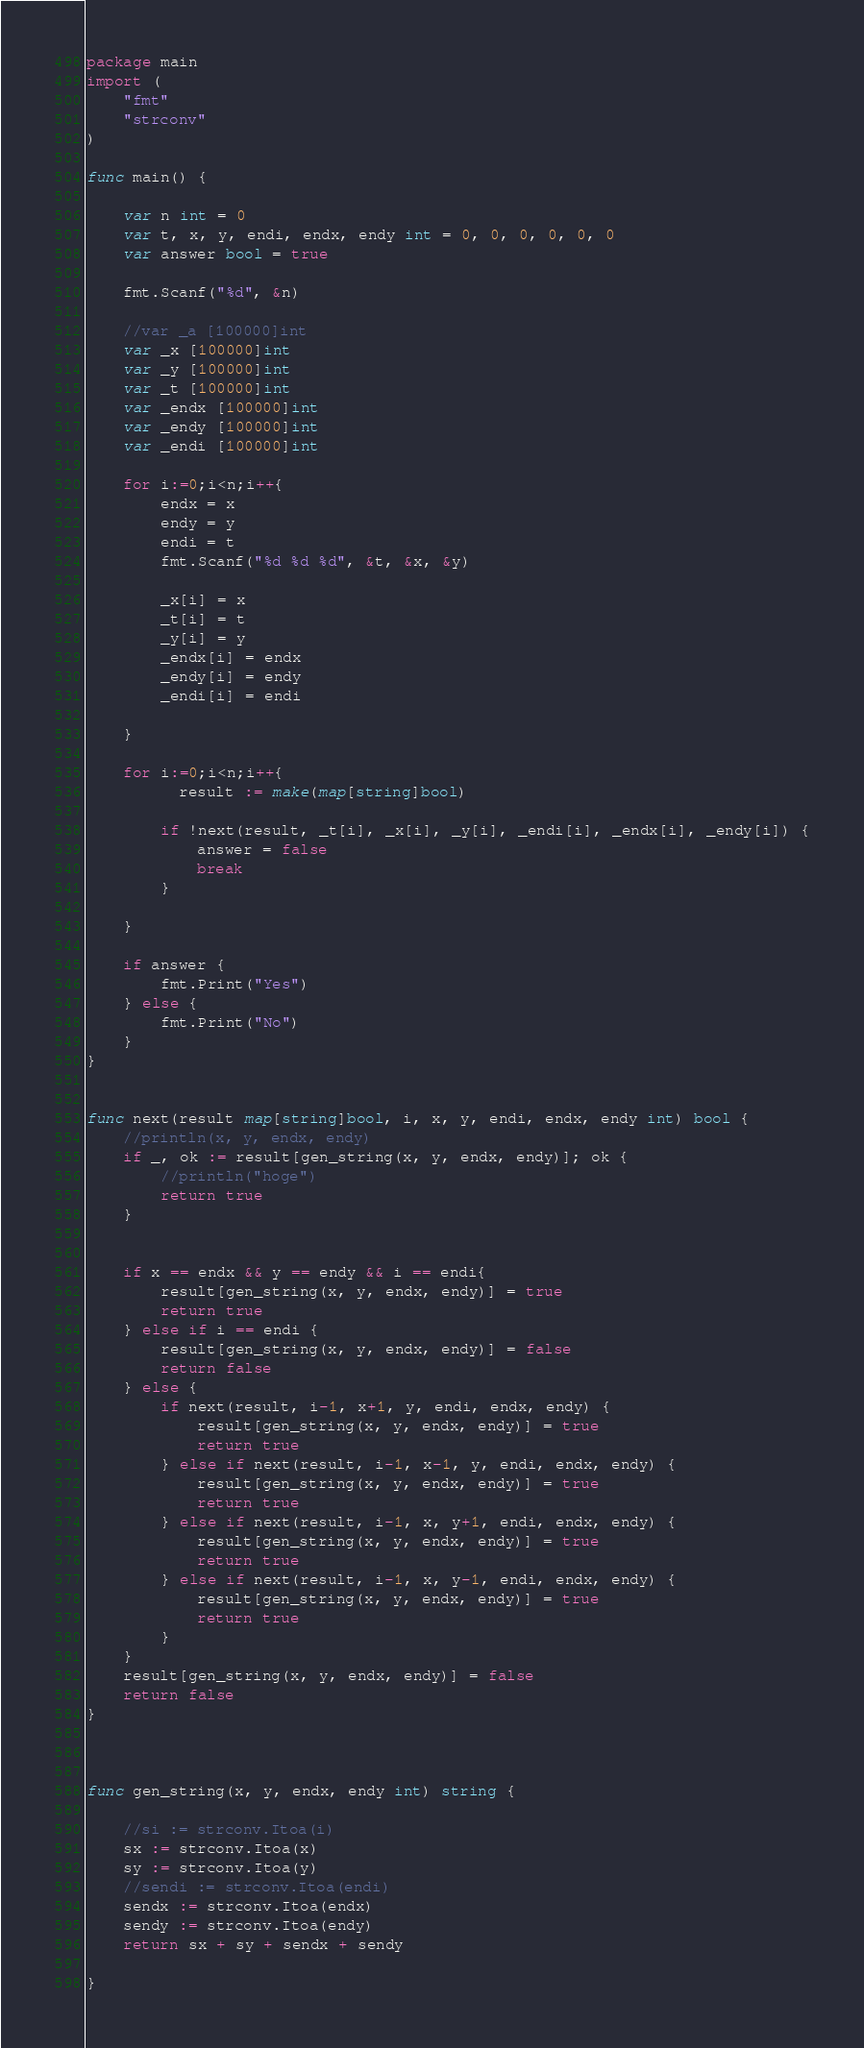<code> <loc_0><loc_0><loc_500><loc_500><_Go_>package main
import (
    "fmt"
    "strconv"
)

func main() {

    var n int = 0
    var t, x, y, endi, endx, endy int = 0, 0, 0, 0, 0, 0
    var answer bool = true

    fmt.Scanf("%d", &n)

    //var _a [100000]int
    var _x [100000]int
    var _y [100000]int
    var _t [100000]int
    var _endx [100000]int
    var _endy [100000]int
    var _endi [100000]int

    for i:=0;i<n;i++{
        endx = x
        endy = y
        endi = t
        fmt.Scanf("%d %d %d", &t, &x, &y)

        _x[i] = x
        _t[i] = t
        _y[i] = y
        _endx[i] = endx
        _endy[i] = endy
        _endi[i] = endi

    }

    for i:=0;i<n;i++{
          result := make(map[string]bool)

        if !next(result, _t[i], _x[i], _y[i], _endi[i], _endx[i], _endy[i]) {
            answer = false
            break
        }

    }

    if answer {
        fmt.Print("Yes")
    } else {
        fmt.Print("No")
    }
}


func next(result map[string]bool, i, x, y, endi, endx, endy int) bool {
    //println(x, y, endx, endy)
    if _, ok := result[gen_string(x, y, endx, endy)]; ok {
        //println("hoge")
        return true
    }


    if x == endx && y == endy && i == endi{
        result[gen_string(x, y, endx, endy)] = true
        return true
    } else if i == endi {
        result[gen_string(x, y, endx, endy)] = false
        return false
    } else {
        if next(result, i-1, x+1, y, endi, endx, endy) {
            result[gen_string(x, y, endx, endy)] = true
            return true
        } else if next(result, i-1, x-1, y, endi, endx, endy) {
            result[gen_string(x, y, endx, endy)] = true
            return true
        } else if next(result, i-1, x, y+1, endi, endx, endy) {
            result[gen_string(x, y, endx, endy)] = true
            return true
        } else if next(result, i-1, x, y-1, endi, endx, endy) {
            result[gen_string(x, y, endx, endy)] = true
            return true
        }
    }
    result[gen_string(x, y, endx, endy)] = false
    return false
}



func gen_string(x, y, endx, endy int) string {

    //si := strconv.Itoa(i)
    sx := strconv.Itoa(x)
    sy := strconv.Itoa(y)
    //sendi := strconv.Itoa(endi)
    sendx := strconv.Itoa(endx)
    sendy := strconv.Itoa(endy)
    return sx + sy + sendx + sendy

}</code> 